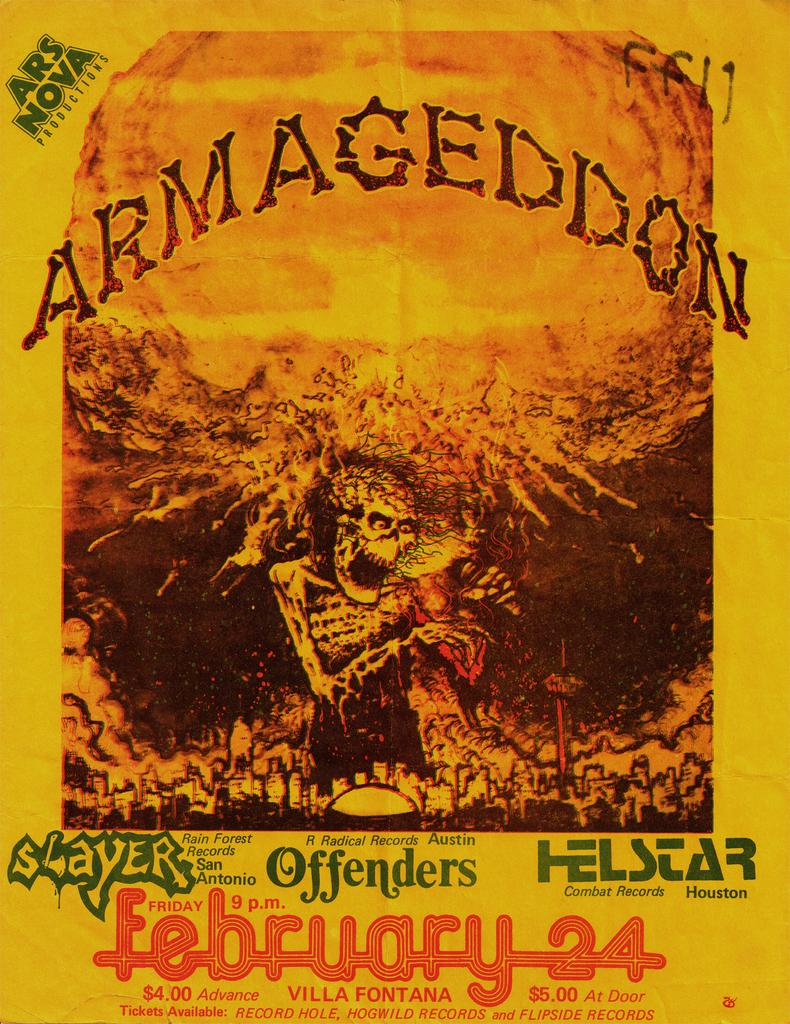<image>
Present a compact description of the photo's key features. a poster that says 'armageddon' on it at the top 